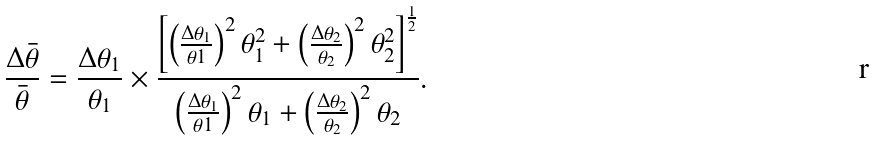Convert formula to latex. <formula><loc_0><loc_0><loc_500><loc_500>\frac { \Delta \bar { \theta } } { \bar { \theta } } = \frac { \Delta \theta _ { 1 } } { \theta _ { 1 } } \times \frac { \left [ \left ( \frac { \Delta \theta _ { 1 } } { \theta 1 } \right ) ^ { 2 } \theta _ { 1 } ^ { 2 } + \left ( \frac { \Delta \theta _ { 2 } } { \theta _ { 2 } } \right ) ^ { 2 } \theta _ { 2 } ^ { 2 } \right ] ^ { \frac { 1 } { 2 } } } { \left ( \frac { \Delta \theta _ { 1 } } { \theta 1 } \right ) ^ { 2 } \theta _ { 1 } + \left ( \frac { \Delta \theta _ { 2 } } { \theta _ { 2 } } \right ) ^ { 2 } \theta _ { 2 } } .</formula> 